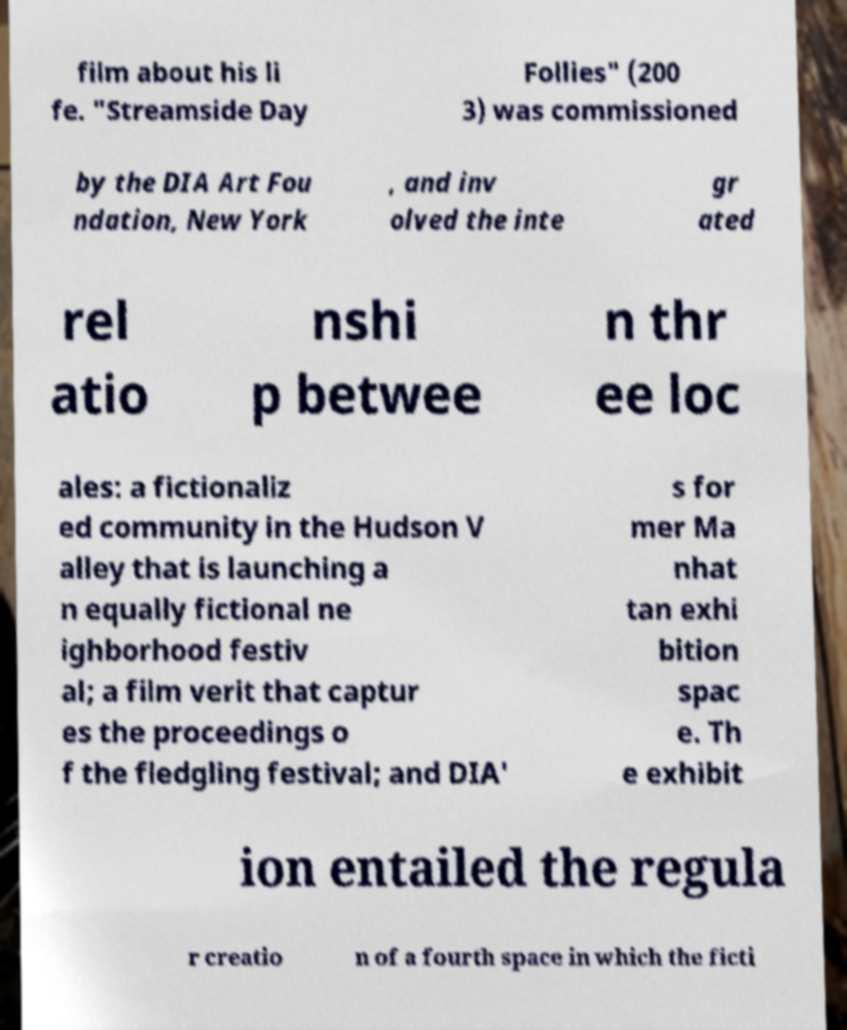Can you read and provide the text displayed in the image?This photo seems to have some interesting text. Can you extract and type it out for me? film about his li fe. "Streamside Day Follies" (200 3) was commissioned by the DIA Art Fou ndation, New York , and inv olved the inte gr ated rel atio nshi p betwee n thr ee loc ales: a fictionaliz ed community in the Hudson V alley that is launching a n equally fictional ne ighborhood festiv al; a film verit that captur es the proceedings o f the fledgling festival; and DIA' s for mer Ma nhat tan exhi bition spac e. Th e exhibit ion entailed the regula r creatio n of a fourth space in which the ficti 